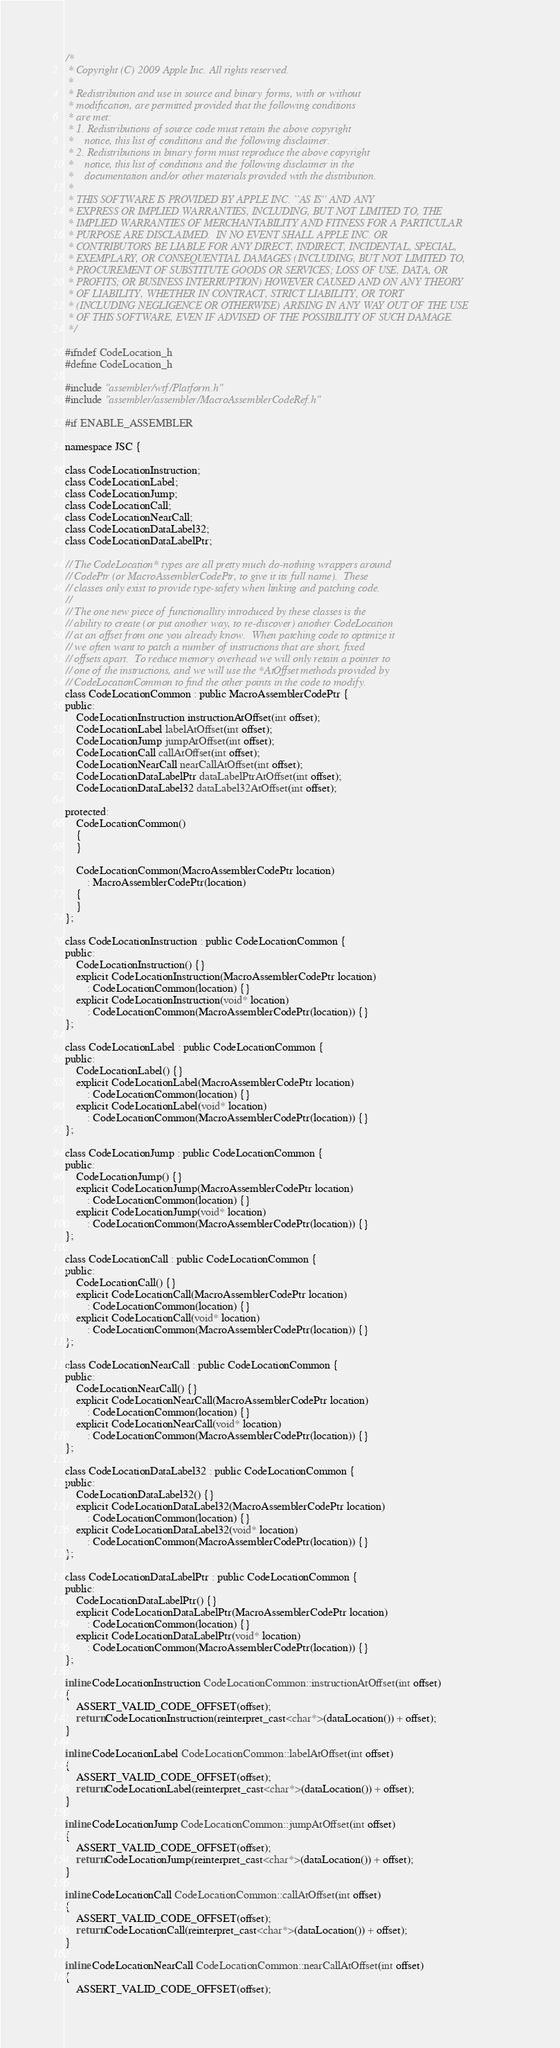<code> <loc_0><loc_0><loc_500><loc_500><_C_>/*
 * Copyright (C) 2009 Apple Inc. All rights reserved.
 *
 * Redistribution and use in source and binary forms, with or without
 * modification, are permitted provided that the following conditions
 * are met:
 * 1. Redistributions of source code must retain the above copyright
 *    notice, this list of conditions and the following disclaimer.
 * 2. Redistributions in binary form must reproduce the above copyright
 *    notice, this list of conditions and the following disclaimer in the
 *    documentation and/or other materials provided with the distribution.
 *
 * THIS SOFTWARE IS PROVIDED BY APPLE INC. ``AS IS'' AND ANY
 * EXPRESS OR IMPLIED WARRANTIES, INCLUDING, BUT NOT LIMITED TO, THE
 * IMPLIED WARRANTIES OF MERCHANTABILITY AND FITNESS FOR A PARTICULAR
 * PURPOSE ARE DISCLAIMED.  IN NO EVENT SHALL APPLE INC. OR
 * CONTRIBUTORS BE LIABLE FOR ANY DIRECT, INDIRECT, INCIDENTAL, SPECIAL,
 * EXEMPLARY, OR CONSEQUENTIAL DAMAGES (INCLUDING, BUT NOT LIMITED TO,
 * PROCUREMENT OF SUBSTITUTE GOODS OR SERVICES; LOSS OF USE, DATA, OR
 * PROFITS; OR BUSINESS INTERRUPTION) HOWEVER CAUSED AND ON ANY THEORY
 * OF LIABILITY, WHETHER IN CONTRACT, STRICT LIABILITY, OR TORT
 * (INCLUDING NEGLIGENCE OR OTHERWISE) ARISING IN ANY WAY OUT OF THE USE
 * OF THIS SOFTWARE, EVEN IF ADVISED OF THE POSSIBILITY OF SUCH DAMAGE. 
 */

#ifndef CodeLocation_h
#define CodeLocation_h

#include "assembler/wtf/Platform.h"
#include "assembler/assembler/MacroAssemblerCodeRef.h"

#if ENABLE_ASSEMBLER

namespace JSC {

class CodeLocationInstruction;
class CodeLocationLabel;
class CodeLocationJump;
class CodeLocationCall;
class CodeLocationNearCall;
class CodeLocationDataLabel32;
class CodeLocationDataLabelPtr;

// The CodeLocation* types are all pretty much do-nothing wrappers around
// CodePtr (or MacroAssemblerCodePtr, to give it its full name).  These
// classes only exist to provide type-safety when linking and patching code.
//
// The one new piece of functionallity introduced by these classes is the
// ability to create (or put another way, to re-discover) another CodeLocation
// at an offset from one you already know.  When patching code to optimize it
// we often want to patch a number of instructions that are short, fixed
// offsets apart.  To reduce memory overhead we will only retain a pointer to
// one of the instructions, and we will use the *AtOffset methods provided by
// CodeLocationCommon to find the other points in the code to modify.
class CodeLocationCommon : public MacroAssemblerCodePtr {
public:
    CodeLocationInstruction instructionAtOffset(int offset);
    CodeLocationLabel labelAtOffset(int offset);
    CodeLocationJump jumpAtOffset(int offset);
    CodeLocationCall callAtOffset(int offset);
    CodeLocationNearCall nearCallAtOffset(int offset);
    CodeLocationDataLabelPtr dataLabelPtrAtOffset(int offset);
    CodeLocationDataLabel32 dataLabel32AtOffset(int offset);

protected:
    CodeLocationCommon()
    {
    }

    CodeLocationCommon(MacroAssemblerCodePtr location)
        : MacroAssemblerCodePtr(location)
    {
    }
};

class CodeLocationInstruction : public CodeLocationCommon {
public:
    CodeLocationInstruction() {}
    explicit CodeLocationInstruction(MacroAssemblerCodePtr location)
        : CodeLocationCommon(location) {}
    explicit CodeLocationInstruction(void* location)
        : CodeLocationCommon(MacroAssemblerCodePtr(location)) {}
};

class CodeLocationLabel : public CodeLocationCommon {
public:
    CodeLocationLabel() {}
    explicit CodeLocationLabel(MacroAssemblerCodePtr location)
        : CodeLocationCommon(location) {}
    explicit CodeLocationLabel(void* location)
        : CodeLocationCommon(MacroAssemblerCodePtr(location)) {}
};

class CodeLocationJump : public CodeLocationCommon {
public:
    CodeLocationJump() {}
    explicit CodeLocationJump(MacroAssemblerCodePtr location)
        : CodeLocationCommon(location) {}
    explicit CodeLocationJump(void* location)
        : CodeLocationCommon(MacroAssemblerCodePtr(location)) {}
};

class CodeLocationCall : public CodeLocationCommon {
public:
    CodeLocationCall() {}
    explicit CodeLocationCall(MacroAssemblerCodePtr location)
        : CodeLocationCommon(location) {}
    explicit CodeLocationCall(void* location)
        : CodeLocationCommon(MacroAssemblerCodePtr(location)) {}
};

class CodeLocationNearCall : public CodeLocationCommon {
public:
    CodeLocationNearCall() {}
    explicit CodeLocationNearCall(MacroAssemblerCodePtr location)
        : CodeLocationCommon(location) {}
    explicit CodeLocationNearCall(void* location)
        : CodeLocationCommon(MacroAssemblerCodePtr(location)) {}
};

class CodeLocationDataLabel32 : public CodeLocationCommon {
public:
    CodeLocationDataLabel32() {}
    explicit CodeLocationDataLabel32(MacroAssemblerCodePtr location)
        : CodeLocationCommon(location) {}
    explicit CodeLocationDataLabel32(void* location)
        : CodeLocationCommon(MacroAssemblerCodePtr(location)) {}
};

class CodeLocationDataLabelPtr : public CodeLocationCommon {
public:
    CodeLocationDataLabelPtr() {}
    explicit CodeLocationDataLabelPtr(MacroAssemblerCodePtr location)
        : CodeLocationCommon(location) {}
    explicit CodeLocationDataLabelPtr(void* location)
        : CodeLocationCommon(MacroAssemblerCodePtr(location)) {}
};

inline CodeLocationInstruction CodeLocationCommon::instructionAtOffset(int offset)
{
    ASSERT_VALID_CODE_OFFSET(offset);
    return CodeLocationInstruction(reinterpret_cast<char*>(dataLocation()) + offset);
}

inline CodeLocationLabel CodeLocationCommon::labelAtOffset(int offset)
{
    ASSERT_VALID_CODE_OFFSET(offset);
    return CodeLocationLabel(reinterpret_cast<char*>(dataLocation()) + offset);
}

inline CodeLocationJump CodeLocationCommon::jumpAtOffset(int offset)
{
    ASSERT_VALID_CODE_OFFSET(offset);
    return CodeLocationJump(reinterpret_cast<char*>(dataLocation()) + offset);
}

inline CodeLocationCall CodeLocationCommon::callAtOffset(int offset)
{
    ASSERT_VALID_CODE_OFFSET(offset);
    return CodeLocationCall(reinterpret_cast<char*>(dataLocation()) + offset);
}

inline CodeLocationNearCall CodeLocationCommon::nearCallAtOffset(int offset)
{
    ASSERT_VALID_CODE_OFFSET(offset);</code> 